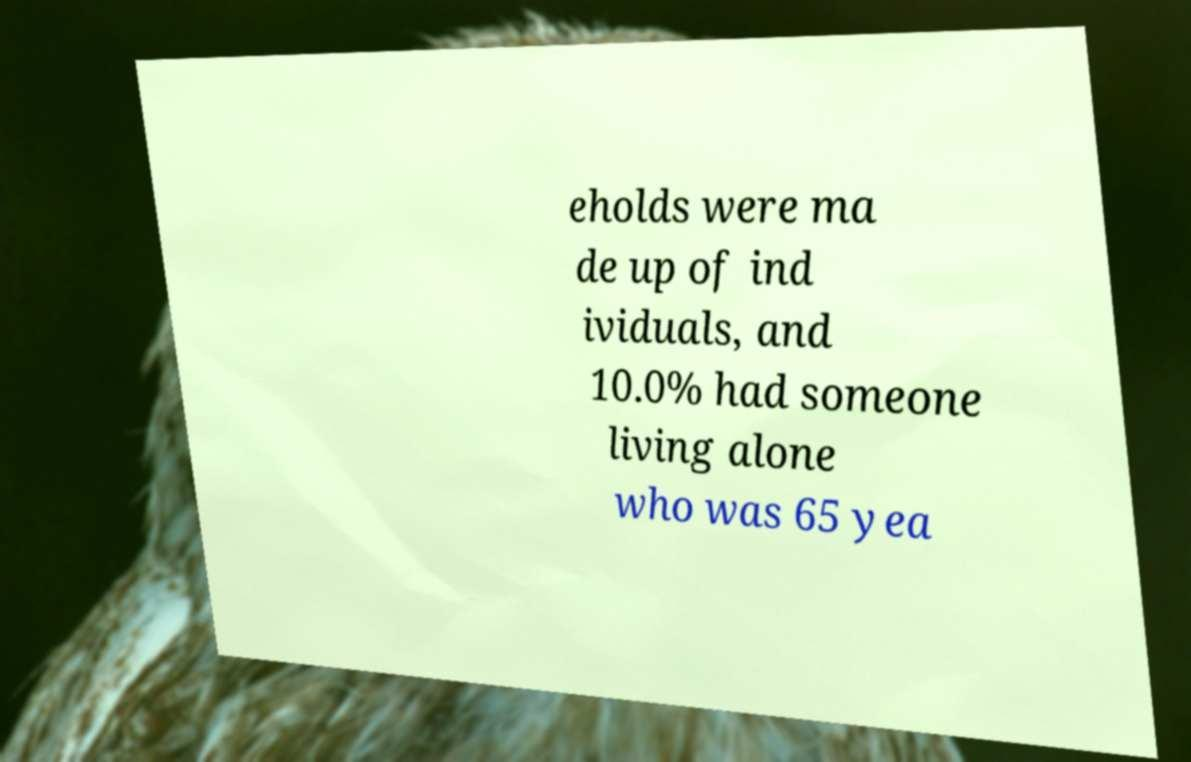What messages or text are displayed in this image? I need them in a readable, typed format. eholds were ma de up of ind ividuals, and 10.0% had someone living alone who was 65 yea 